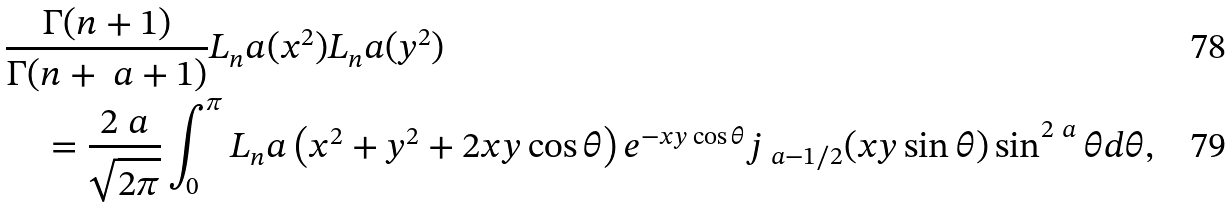<formula> <loc_0><loc_0><loc_500><loc_500>& \frac { \Gamma ( n + 1 ) } { \Gamma ( n + \ a + 1 ) } L _ { n } ^ { \ } a ( x ^ { 2 } ) L _ { n } ^ { \ } a ( y ^ { 2 } ) \\ & \quad = \frac { 2 ^ { \ } a } { \sqrt { 2 \pi } } \int _ { 0 } ^ { \pi } L _ { n } ^ { \ } a \left ( x ^ { 2 } + y ^ { 2 } + 2 x y \cos \theta \right ) e ^ { - x y \cos \theta } j _ { \ a - 1 / 2 } ( x y \sin \theta ) \sin ^ { 2 \ a } \theta d \theta ,</formula> 